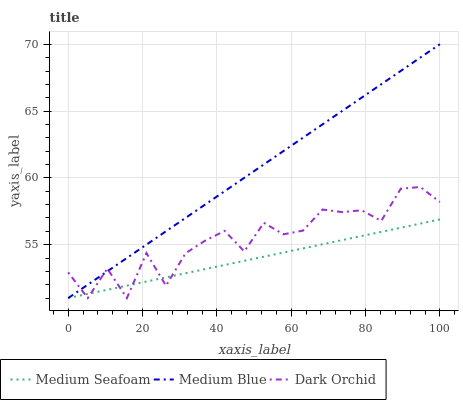Does Medium Seafoam have the minimum area under the curve?
Answer yes or no. Yes. Does Dark Orchid have the minimum area under the curve?
Answer yes or no. No. Does Dark Orchid have the maximum area under the curve?
Answer yes or no. No. Is Medium Seafoam the smoothest?
Answer yes or no. Yes. Is Dark Orchid the roughest?
Answer yes or no. Yes. Is Dark Orchid the smoothest?
Answer yes or no. No. Is Medium Seafoam the roughest?
Answer yes or no. No. Does Dark Orchid have the highest value?
Answer yes or no. No. 